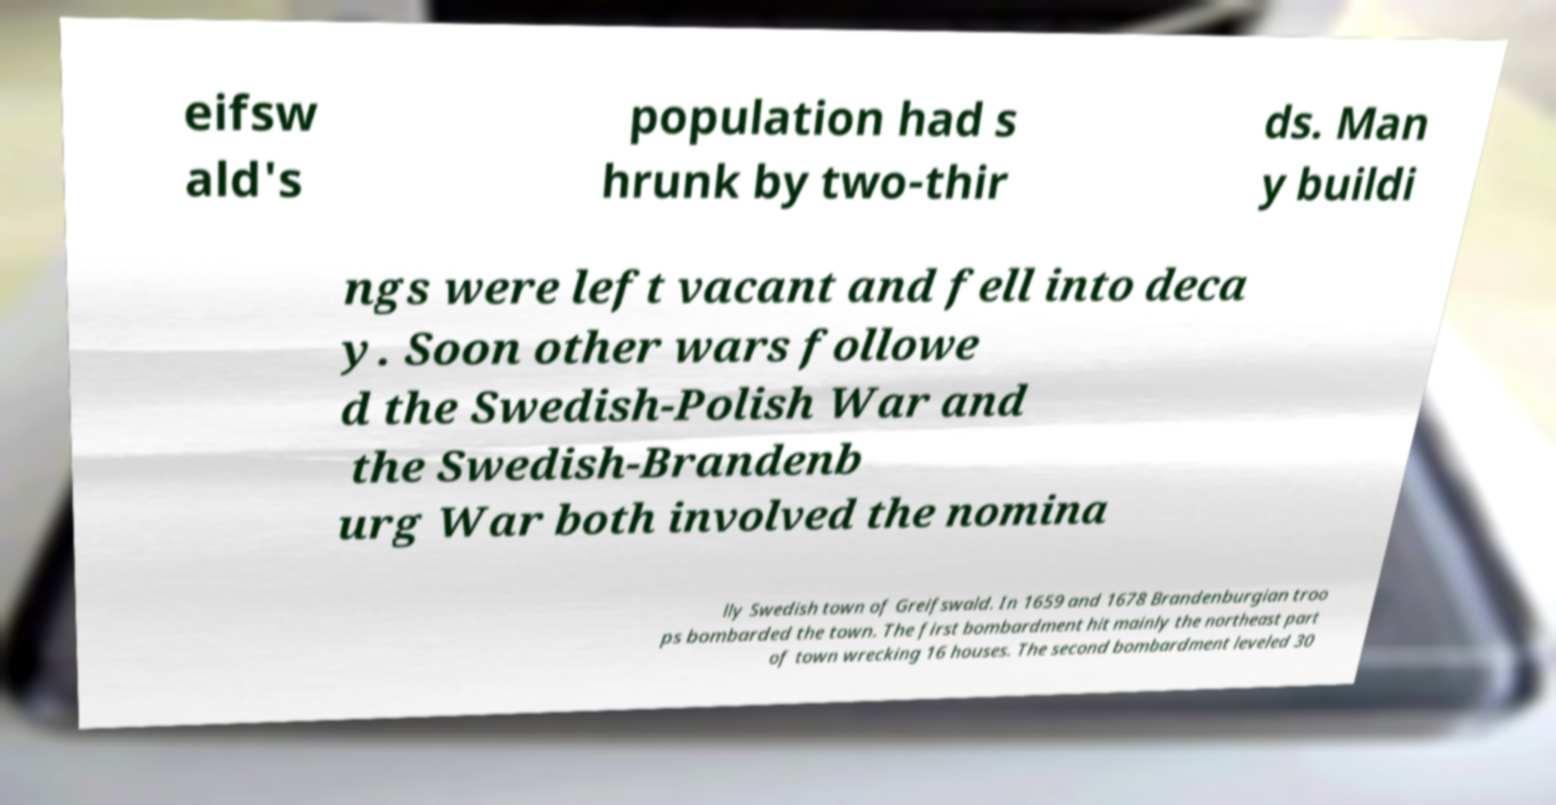Could you assist in decoding the text presented in this image and type it out clearly? eifsw ald's population had s hrunk by two-thir ds. Man y buildi ngs were left vacant and fell into deca y. Soon other wars followe d the Swedish-Polish War and the Swedish-Brandenb urg War both involved the nomina lly Swedish town of Greifswald. In 1659 and 1678 Brandenburgian troo ps bombarded the town. The first bombardment hit mainly the northeast part of town wrecking 16 houses. The second bombardment leveled 30 